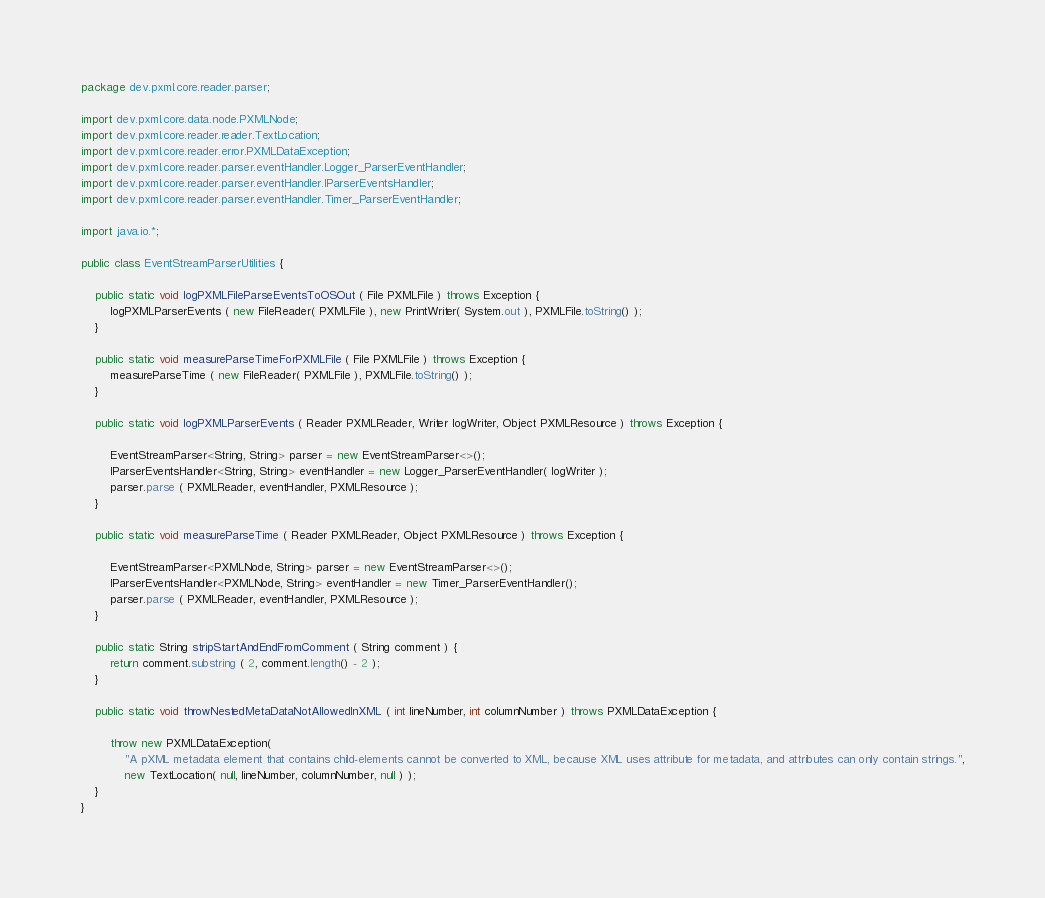Convert code to text. <code><loc_0><loc_0><loc_500><loc_500><_Java_>package dev.pxml.core.reader.parser;

import dev.pxml.core.data.node.PXMLNode;
import dev.pxml.core.reader.reader.TextLocation;
import dev.pxml.core.reader.error.PXMLDataException;
import dev.pxml.core.reader.parser.eventHandler.Logger_ParserEventHandler;
import dev.pxml.core.reader.parser.eventHandler.IParserEventsHandler;
import dev.pxml.core.reader.parser.eventHandler.Timer_ParserEventHandler;

import java.io.*;

public class EventStreamParserUtilities {

    public static void logPXMLFileParseEventsToOSOut ( File PXMLFile ) throws Exception {
        logPXMLParserEvents ( new FileReader( PXMLFile ), new PrintWriter( System.out ), PXMLFile.toString() );
    }

    public static void measureParseTimeForPXMLFile ( File PXMLFile ) throws Exception {
        measureParseTime ( new FileReader( PXMLFile ), PXMLFile.toString() );
    }

    public static void logPXMLParserEvents ( Reader PXMLReader, Writer logWriter, Object PXMLResource ) throws Exception {

        EventStreamParser<String, String> parser = new EventStreamParser<>();
        IParserEventsHandler<String, String> eventHandler = new Logger_ParserEventHandler( logWriter );
        parser.parse ( PXMLReader, eventHandler, PXMLResource );
    }

    public static void measureParseTime ( Reader PXMLReader, Object PXMLResource ) throws Exception {

        EventStreamParser<PXMLNode, String> parser = new EventStreamParser<>();
        IParserEventsHandler<PXMLNode, String> eventHandler = new Timer_ParserEventHandler();
        parser.parse ( PXMLReader, eventHandler, PXMLResource );
    }

    public static String stripStartAndEndFromComment ( String comment ) {
        return comment.substring ( 2, comment.length() - 2 );
    }

    public static void throwNestedMetaDataNotAllowedInXML ( int lineNumber, int columnNumber ) throws PXMLDataException {

        throw new PXMLDataException(
            "A pXML metadata element that contains child-elements cannot be converted to XML, because XML uses attribute for metadata, and attributes can only contain strings.",
            new TextLocation( null, lineNumber, columnNumber, null ) );
    }
}
</code> 